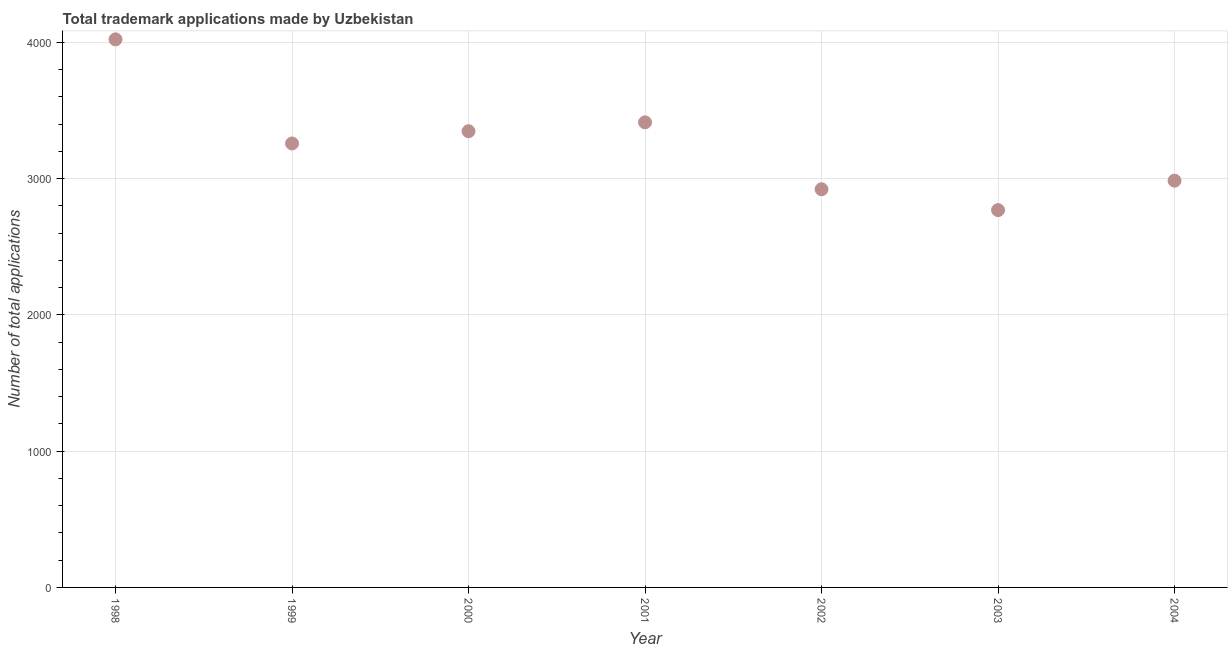What is the number of trademark applications in 2004?
Keep it short and to the point. 2985. Across all years, what is the maximum number of trademark applications?
Ensure brevity in your answer.  4022. Across all years, what is the minimum number of trademark applications?
Your answer should be very brief. 2769. In which year was the number of trademark applications minimum?
Keep it short and to the point. 2003. What is the sum of the number of trademark applications?
Your response must be concise. 2.27e+04. What is the difference between the number of trademark applications in 2000 and 2001?
Your answer should be very brief. -65. What is the average number of trademark applications per year?
Your response must be concise. 3245.29. What is the median number of trademark applications?
Offer a very short reply. 3258. What is the ratio of the number of trademark applications in 1998 to that in 2000?
Your response must be concise. 1.2. Is the number of trademark applications in 1999 less than that in 2004?
Offer a terse response. No. What is the difference between the highest and the second highest number of trademark applications?
Your answer should be very brief. 609. Is the sum of the number of trademark applications in 2003 and 2004 greater than the maximum number of trademark applications across all years?
Your answer should be compact. Yes. What is the difference between the highest and the lowest number of trademark applications?
Provide a short and direct response. 1253. How many dotlines are there?
Keep it short and to the point. 1. How many years are there in the graph?
Offer a terse response. 7. Does the graph contain any zero values?
Your answer should be compact. No. What is the title of the graph?
Your answer should be very brief. Total trademark applications made by Uzbekistan. What is the label or title of the X-axis?
Your response must be concise. Year. What is the label or title of the Y-axis?
Make the answer very short. Number of total applications. What is the Number of total applications in 1998?
Your response must be concise. 4022. What is the Number of total applications in 1999?
Provide a succinct answer. 3258. What is the Number of total applications in 2000?
Provide a succinct answer. 3348. What is the Number of total applications in 2001?
Your response must be concise. 3413. What is the Number of total applications in 2002?
Keep it short and to the point. 2922. What is the Number of total applications in 2003?
Keep it short and to the point. 2769. What is the Number of total applications in 2004?
Your response must be concise. 2985. What is the difference between the Number of total applications in 1998 and 1999?
Your response must be concise. 764. What is the difference between the Number of total applications in 1998 and 2000?
Your response must be concise. 674. What is the difference between the Number of total applications in 1998 and 2001?
Your answer should be very brief. 609. What is the difference between the Number of total applications in 1998 and 2002?
Your response must be concise. 1100. What is the difference between the Number of total applications in 1998 and 2003?
Ensure brevity in your answer.  1253. What is the difference between the Number of total applications in 1998 and 2004?
Make the answer very short. 1037. What is the difference between the Number of total applications in 1999 and 2000?
Offer a terse response. -90. What is the difference between the Number of total applications in 1999 and 2001?
Your answer should be very brief. -155. What is the difference between the Number of total applications in 1999 and 2002?
Your response must be concise. 336. What is the difference between the Number of total applications in 1999 and 2003?
Keep it short and to the point. 489. What is the difference between the Number of total applications in 1999 and 2004?
Keep it short and to the point. 273. What is the difference between the Number of total applications in 2000 and 2001?
Offer a very short reply. -65. What is the difference between the Number of total applications in 2000 and 2002?
Make the answer very short. 426. What is the difference between the Number of total applications in 2000 and 2003?
Make the answer very short. 579. What is the difference between the Number of total applications in 2000 and 2004?
Your answer should be compact. 363. What is the difference between the Number of total applications in 2001 and 2002?
Offer a terse response. 491. What is the difference between the Number of total applications in 2001 and 2003?
Your response must be concise. 644. What is the difference between the Number of total applications in 2001 and 2004?
Your answer should be compact. 428. What is the difference between the Number of total applications in 2002 and 2003?
Keep it short and to the point. 153. What is the difference between the Number of total applications in 2002 and 2004?
Provide a succinct answer. -63. What is the difference between the Number of total applications in 2003 and 2004?
Give a very brief answer. -216. What is the ratio of the Number of total applications in 1998 to that in 1999?
Ensure brevity in your answer.  1.23. What is the ratio of the Number of total applications in 1998 to that in 2000?
Your answer should be compact. 1.2. What is the ratio of the Number of total applications in 1998 to that in 2001?
Offer a very short reply. 1.18. What is the ratio of the Number of total applications in 1998 to that in 2002?
Your answer should be compact. 1.38. What is the ratio of the Number of total applications in 1998 to that in 2003?
Make the answer very short. 1.45. What is the ratio of the Number of total applications in 1998 to that in 2004?
Keep it short and to the point. 1.35. What is the ratio of the Number of total applications in 1999 to that in 2000?
Make the answer very short. 0.97. What is the ratio of the Number of total applications in 1999 to that in 2001?
Offer a terse response. 0.95. What is the ratio of the Number of total applications in 1999 to that in 2002?
Ensure brevity in your answer.  1.11. What is the ratio of the Number of total applications in 1999 to that in 2003?
Give a very brief answer. 1.18. What is the ratio of the Number of total applications in 1999 to that in 2004?
Make the answer very short. 1.09. What is the ratio of the Number of total applications in 2000 to that in 2002?
Your response must be concise. 1.15. What is the ratio of the Number of total applications in 2000 to that in 2003?
Offer a terse response. 1.21. What is the ratio of the Number of total applications in 2000 to that in 2004?
Give a very brief answer. 1.12. What is the ratio of the Number of total applications in 2001 to that in 2002?
Offer a terse response. 1.17. What is the ratio of the Number of total applications in 2001 to that in 2003?
Give a very brief answer. 1.23. What is the ratio of the Number of total applications in 2001 to that in 2004?
Keep it short and to the point. 1.14. What is the ratio of the Number of total applications in 2002 to that in 2003?
Your answer should be very brief. 1.05. What is the ratio of the Number of total applications in 2003 to that in 2004?
Provide a short and direct response. 0.93. 